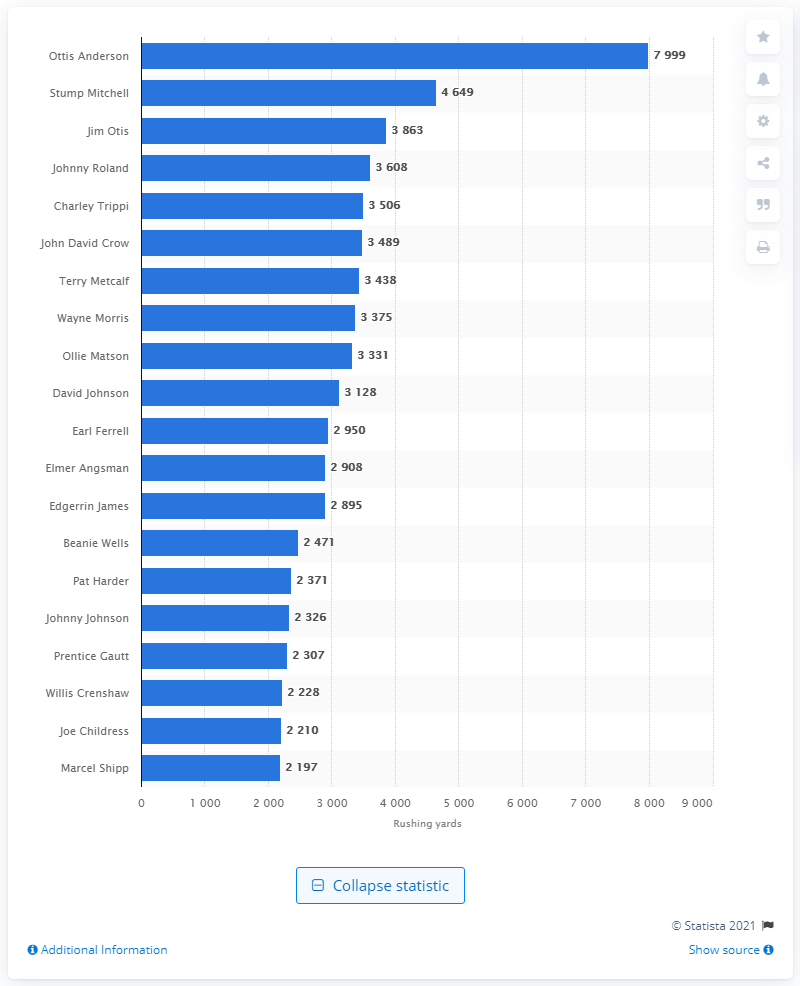Specify some key components in this picture. Ottis Anderson is the career rushing leader of the Arizona Cardinals. 